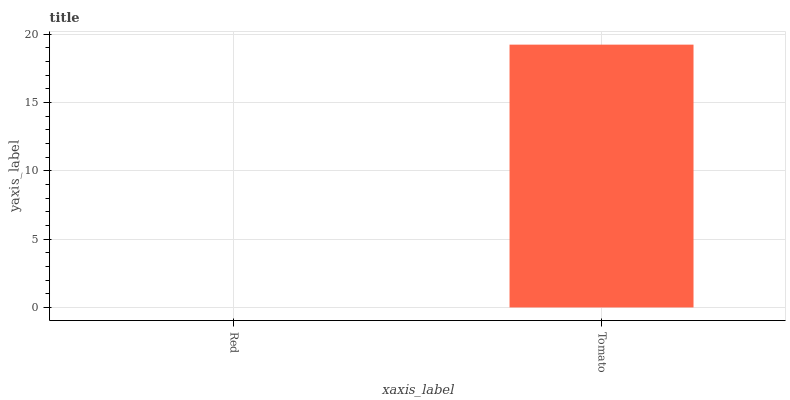Is Red the minimum?
Answer yes or no. Yes. Is Tomato the maximum?
Answer yes or no. Yes. Is Tomato the minimum?
Answer yes or no. No. Is Tomato greater than Red?
Answer yes or no. Yes. Is Red less than Tomato?
Answer yes or no. Yes. Is Red greater than Tomato?
Answer yes or no. No. Is Tomato less than Red?
Answer yes or no. No. Is Tomato the high median?
Answer yes or no. Yes. Is Red the low median?
Answer yes or no. Yes. Is Red the high median?
Answer yes or no. No. Is Tomato the low median?
Answer yes or no. No. 